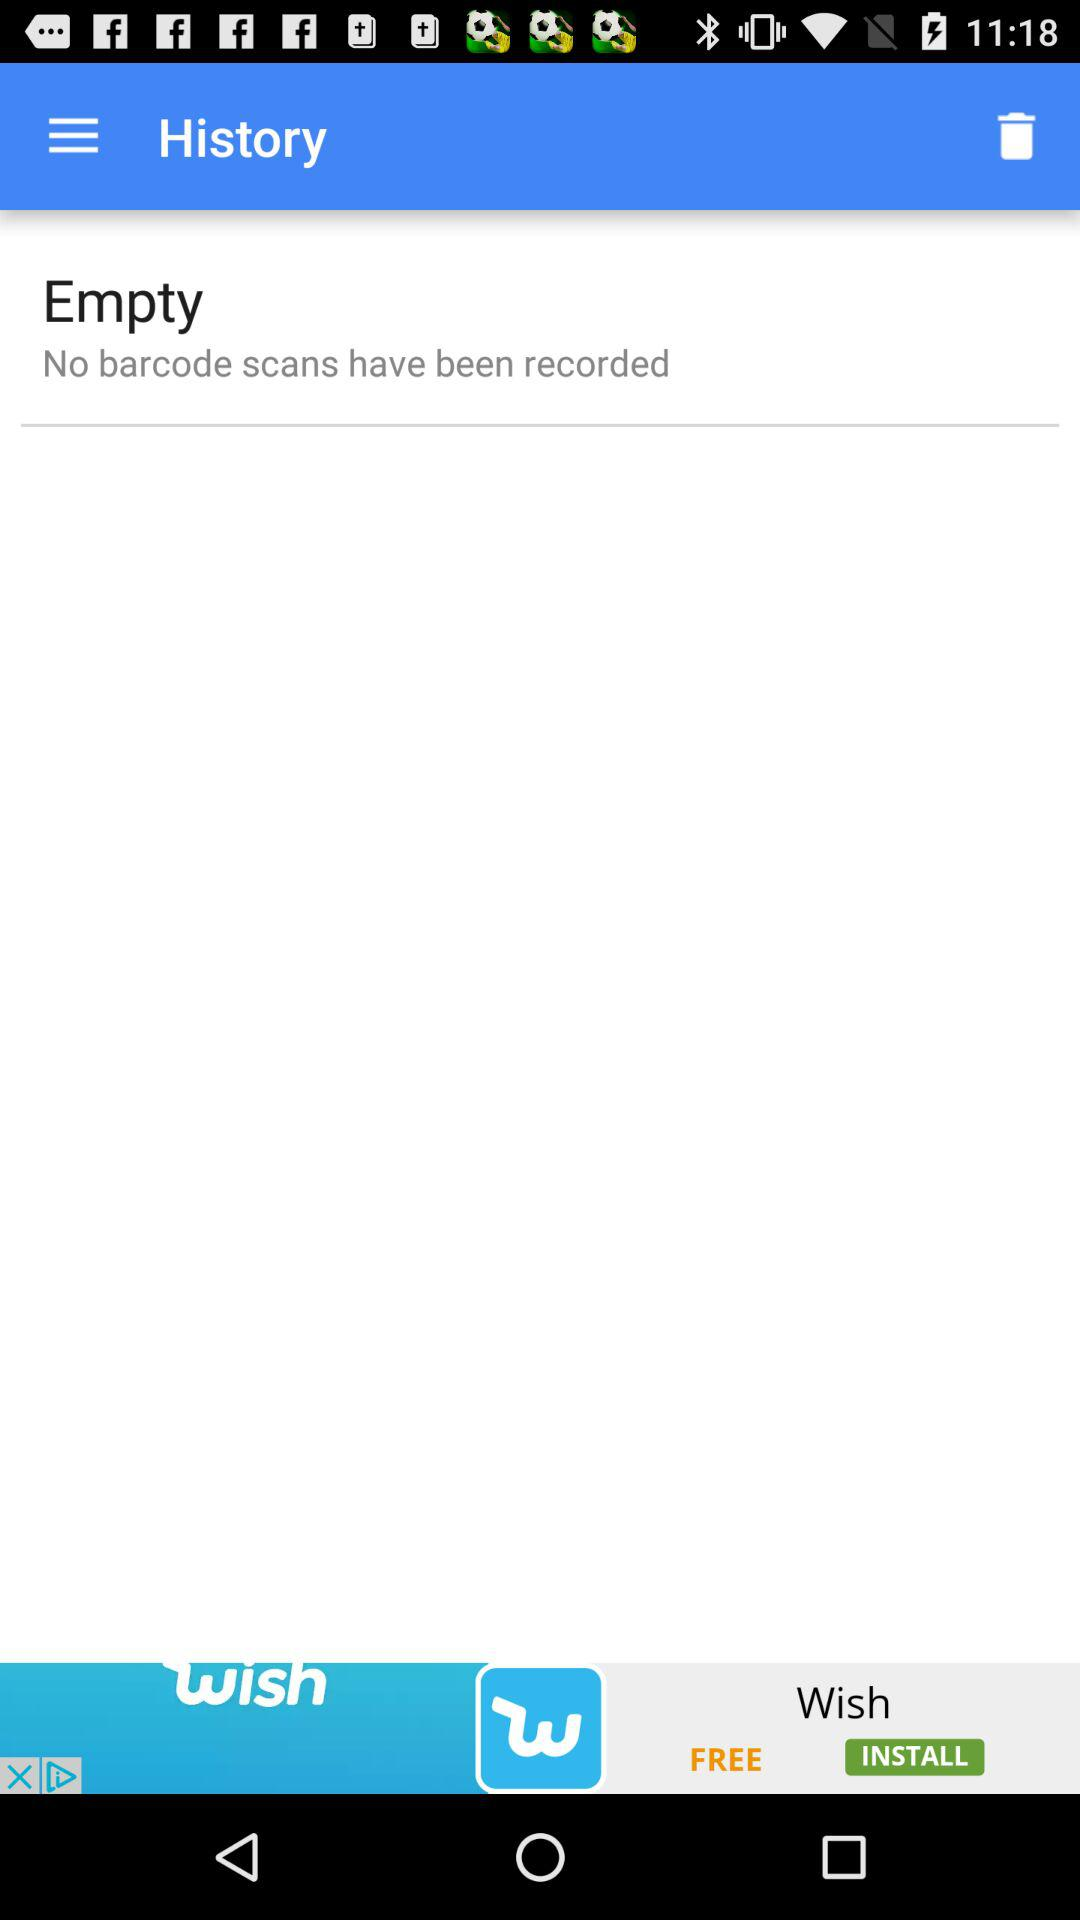Which items are in the trash?
When the provided information is insufficient, respond with <no answer>. <no answer> 